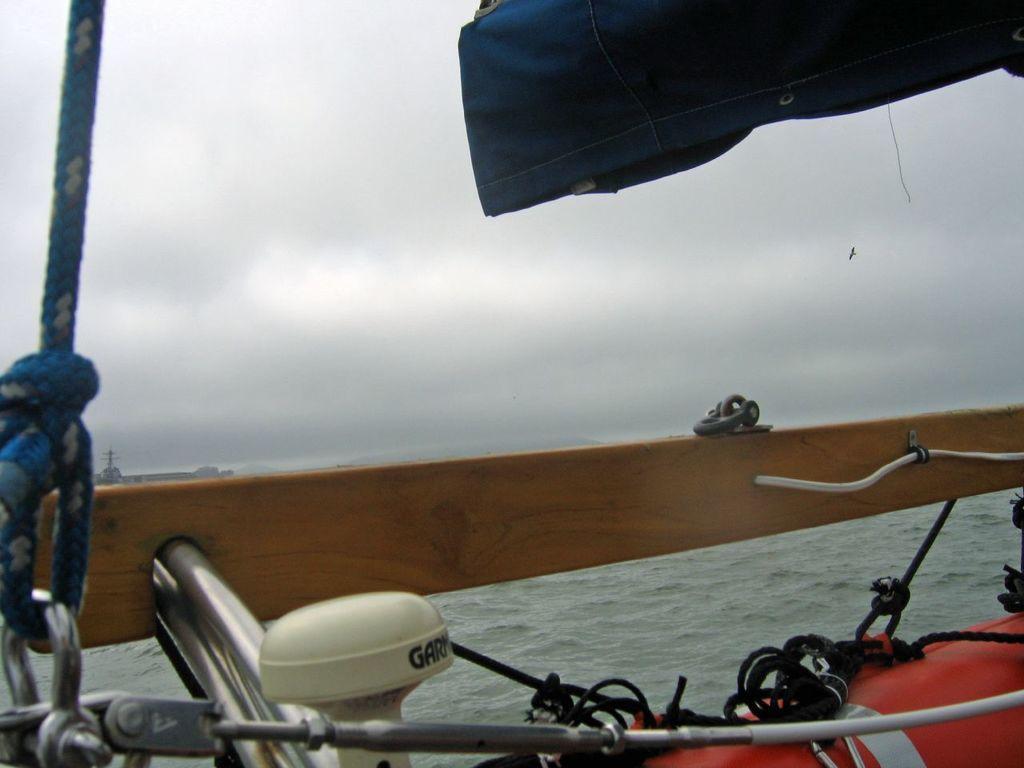How would you summarize this image in a sentence or two? In this image I can see few black colour ropes, an orange object and in the background I can see water. Here I can see something is written. I can also see a bird in air and I can see cloudy sky. 